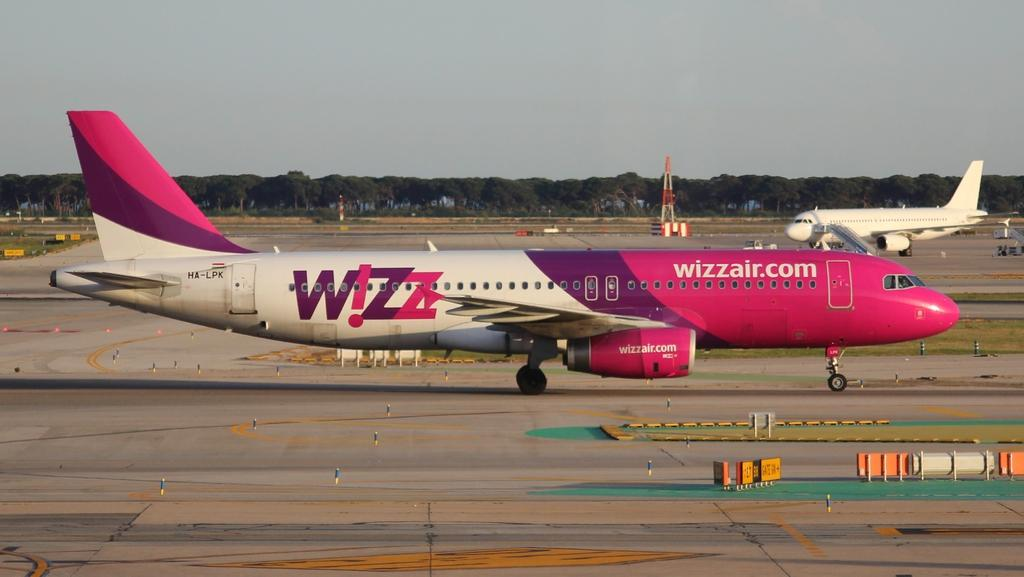What is the main subject of the image? The main subject of the image is airplanes. Can you describe any specific features or structures in the image? Yes, there is a tower on the runway in the image. What type of natural elements can be seen in the image? There are trees in the middle of the image. What is visible at the top of the image? The sky is visible at the top of the image. How many apples can be seen hanging from the trees in the image? There are no apples visible in the image; it only features trees. What type of dirt is present on the runway in the image? There is no dirt visible on the runway in the image; it appears to be a paved surface. 